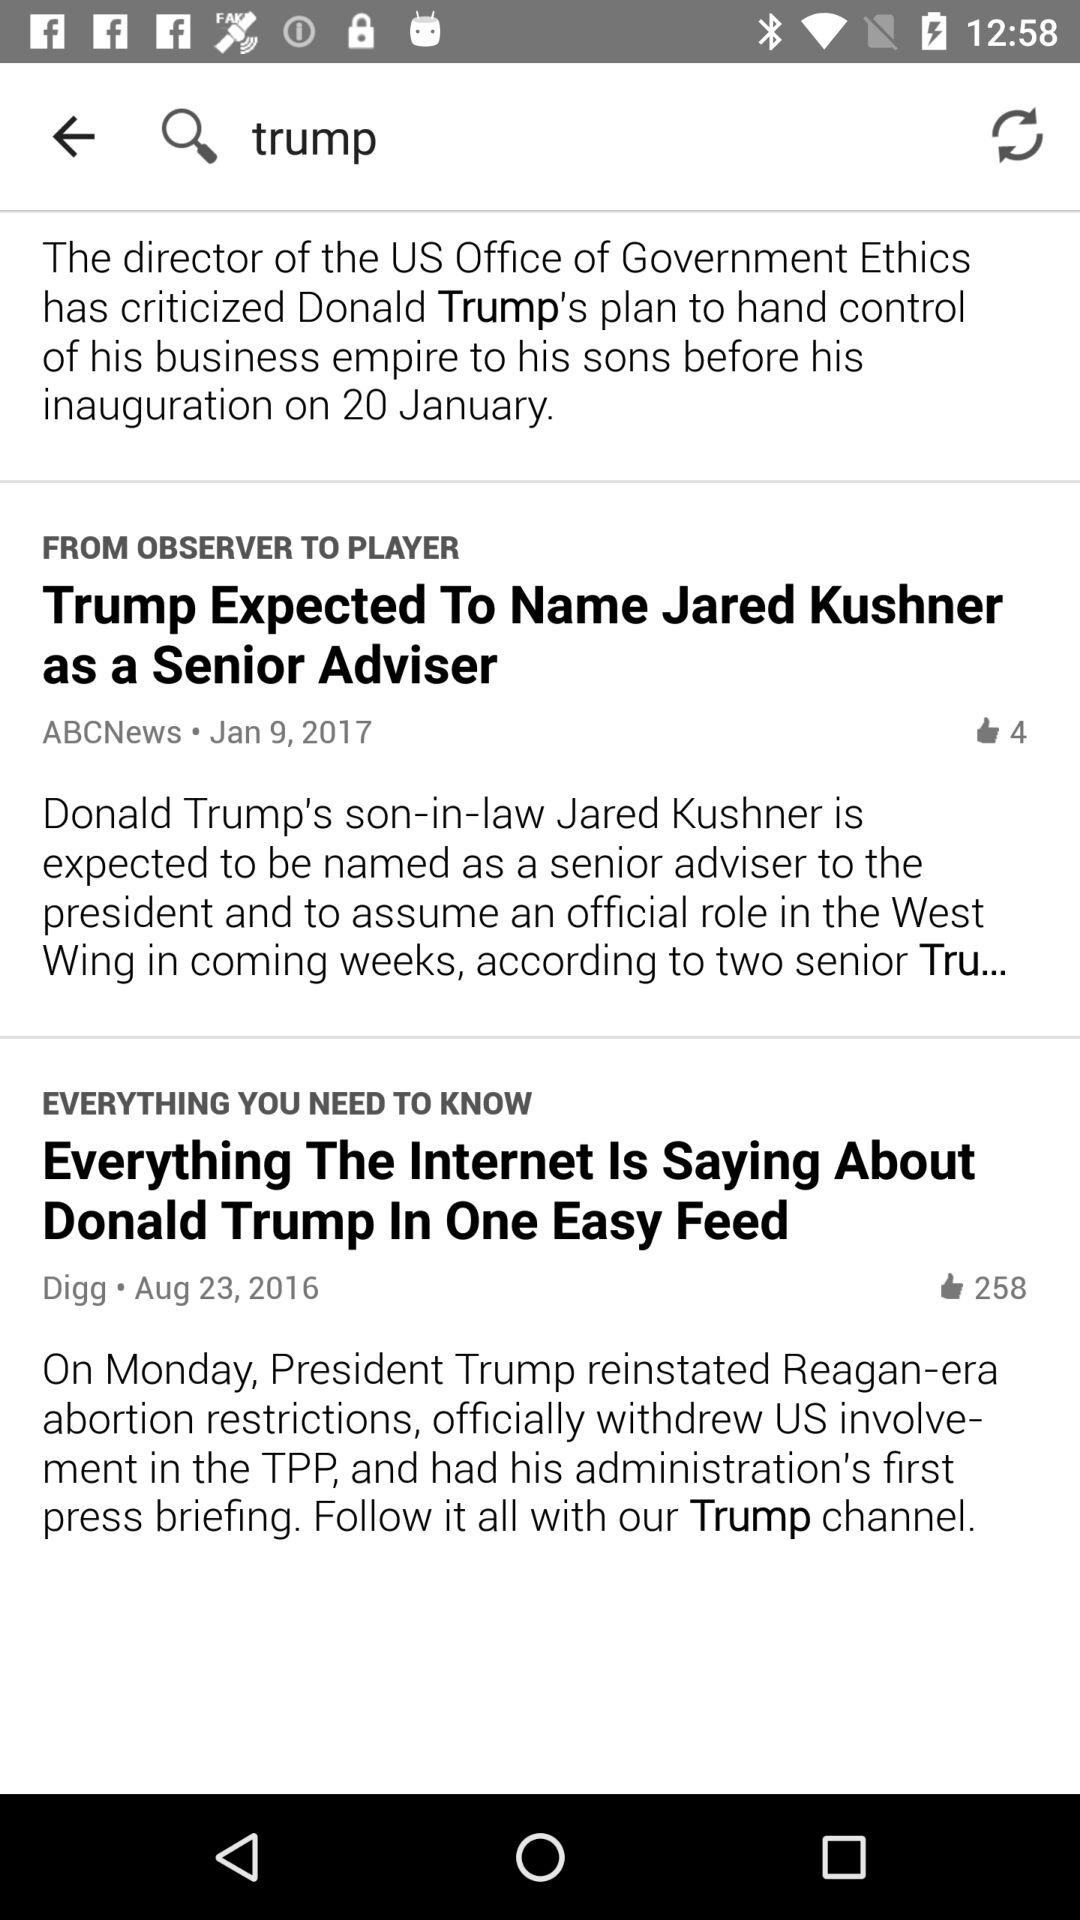What is the headline of the ABCNews? The headline of ABCNews is "Trump Expected To Name Jared Kushner as a Senior Adviser". 